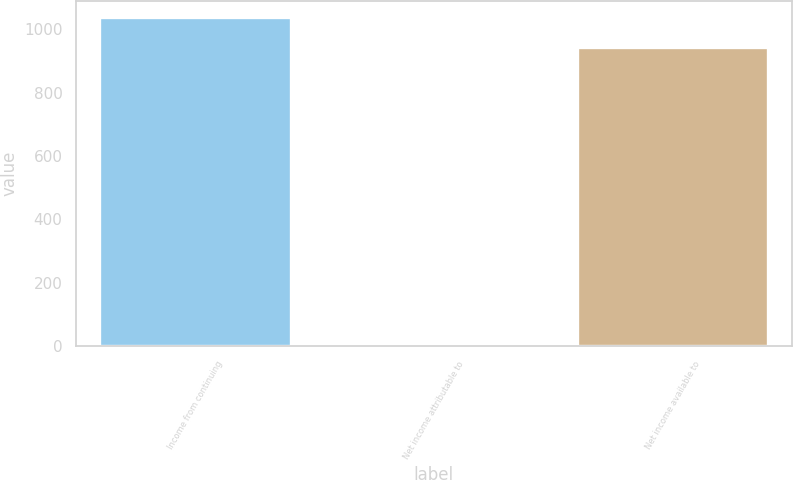<chart> <loc_0><loc_0><loc_500><loc_500><bar_chart><fcel>Income from continuing<fcel>Net income attributable to<fcel>Net income available to<nl><fcel>1038.4<fcel>2<fcel>943<nl></chart> 